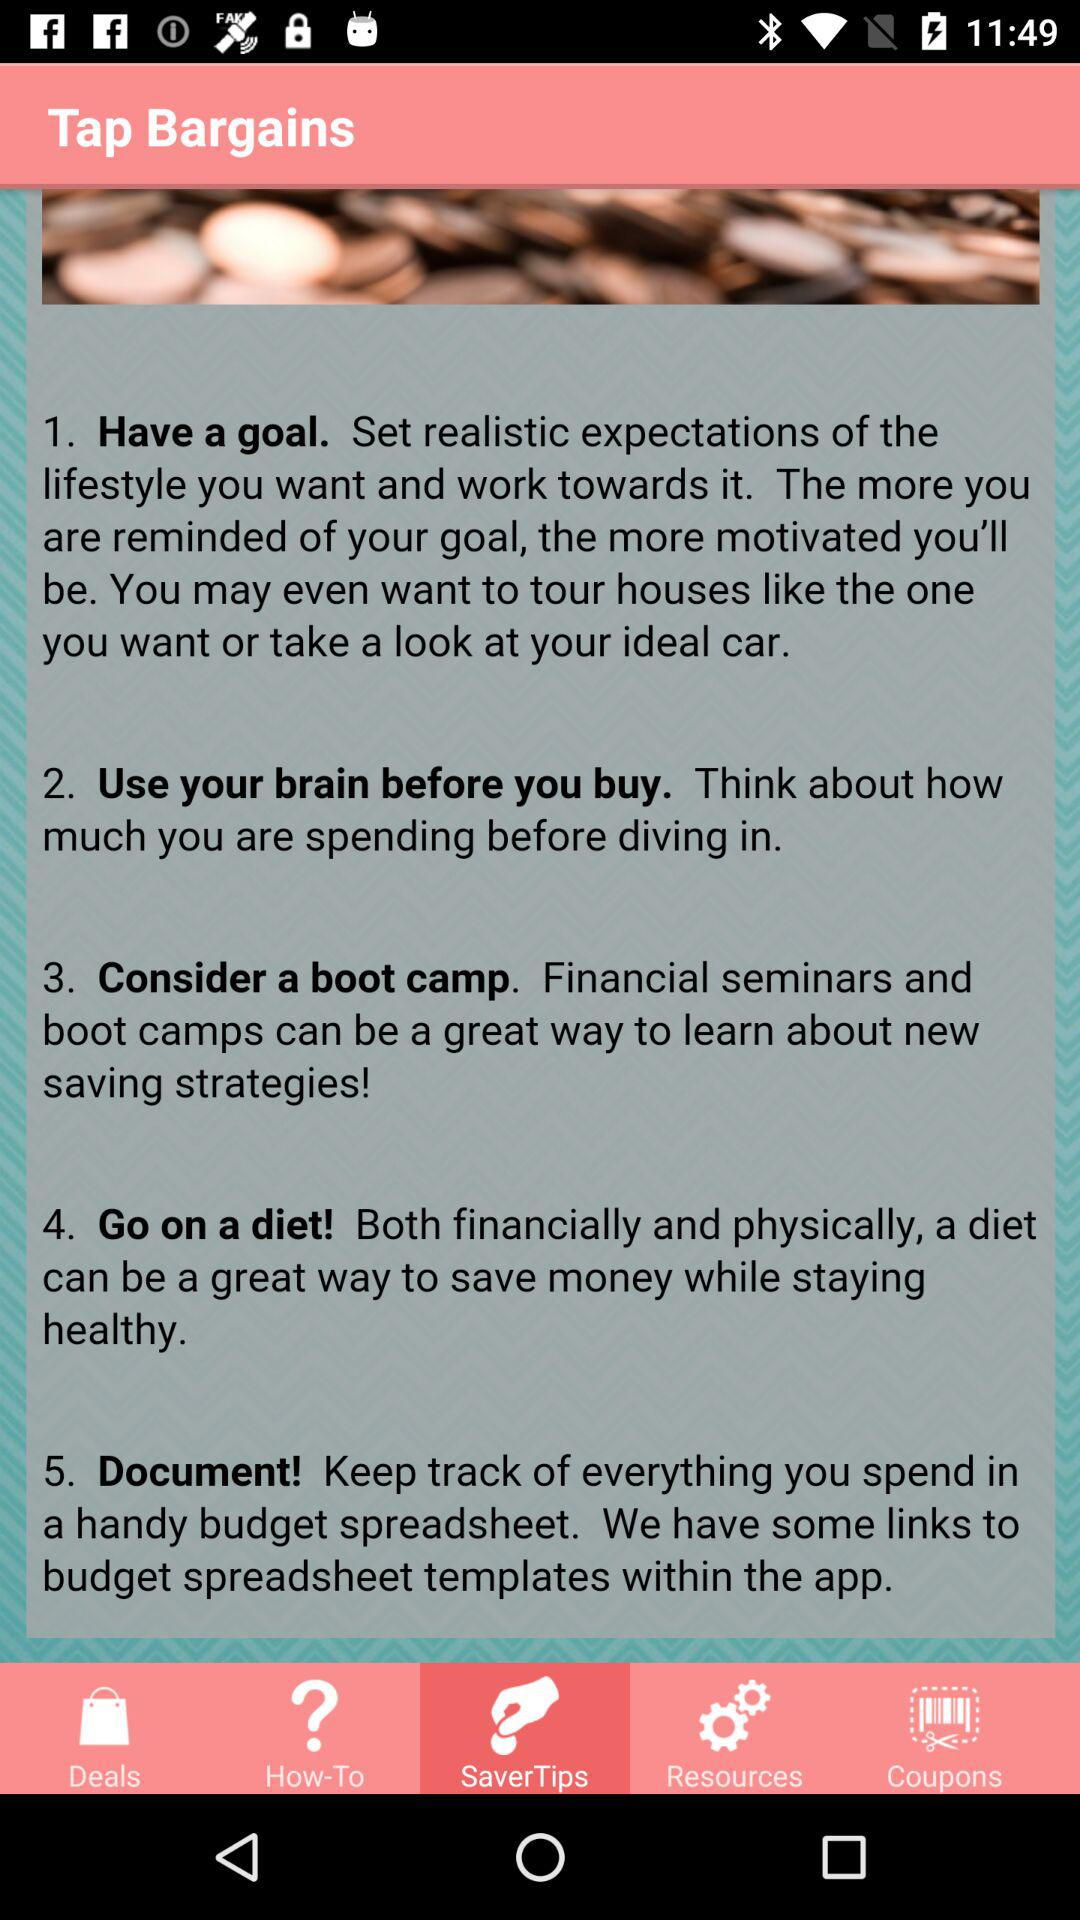Which tab am I on? You are on the "SaverTips" tab. 